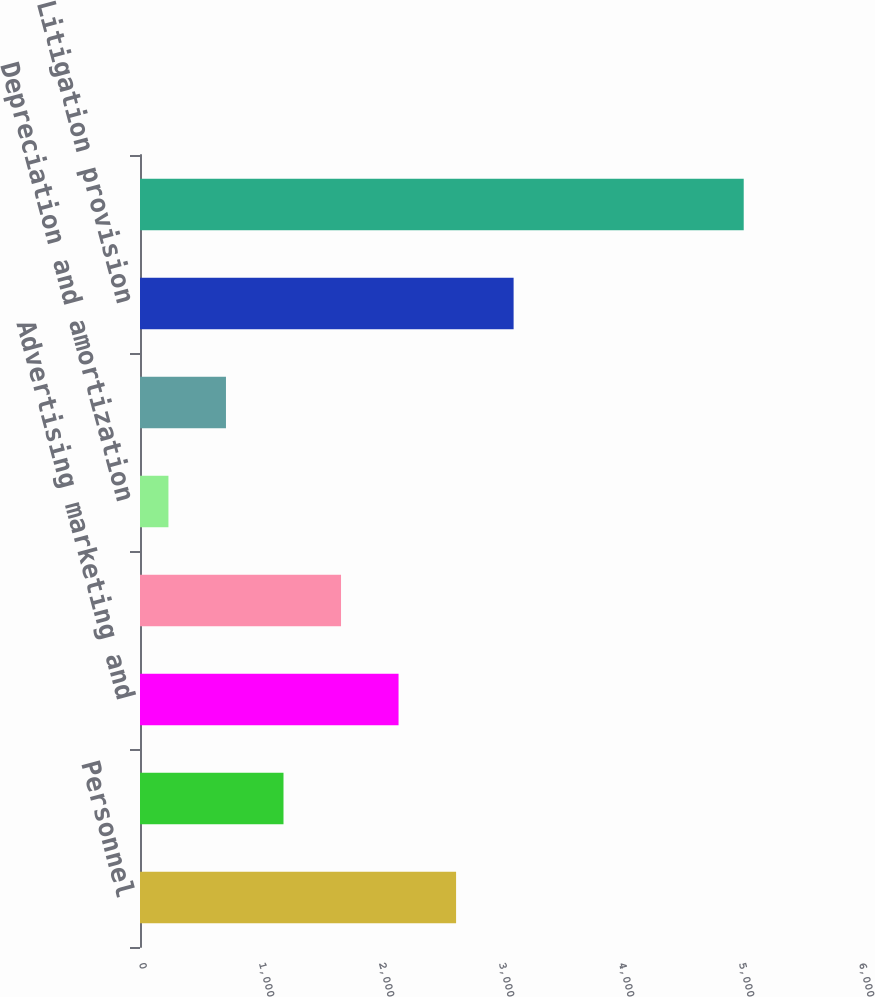Convert chart. <chart><loc_0><loc_0><loc_500><loc_500><bar_chart><fcel>Personnel<fcel>Network EDP and communications<fcel>Advertising marketing and<fcel>Professional and<fcel>Depreciation and amortization<fcel>Administrative and other<fcel>Litigation provision<fcel>Total Operating Expenses<nl><fcel>2634<fcel>1195.8<fcel>2154.6<fcel>1675.2<fcel>237<fcel>716.4<fcel>3113.4<fcel>5031<nl></chart> 